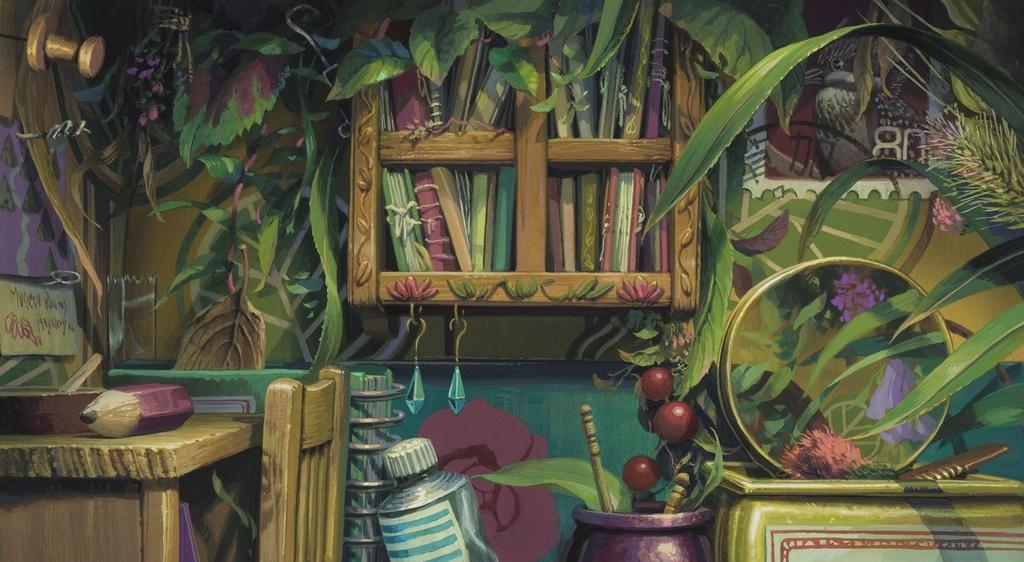Describe this image in one or two sentences. In this image we can see a painting. In the painting there is a cupboard with books. On the cupboard there are earrings. On the wall there is a stamp. On the stamp there is a number and a bird. Also there is a table and chair. On the table there is a pencil and some other items. At the bottom there is bottle and pot with some items. And there is another box with some other things. Also there are leaves and flowers. 